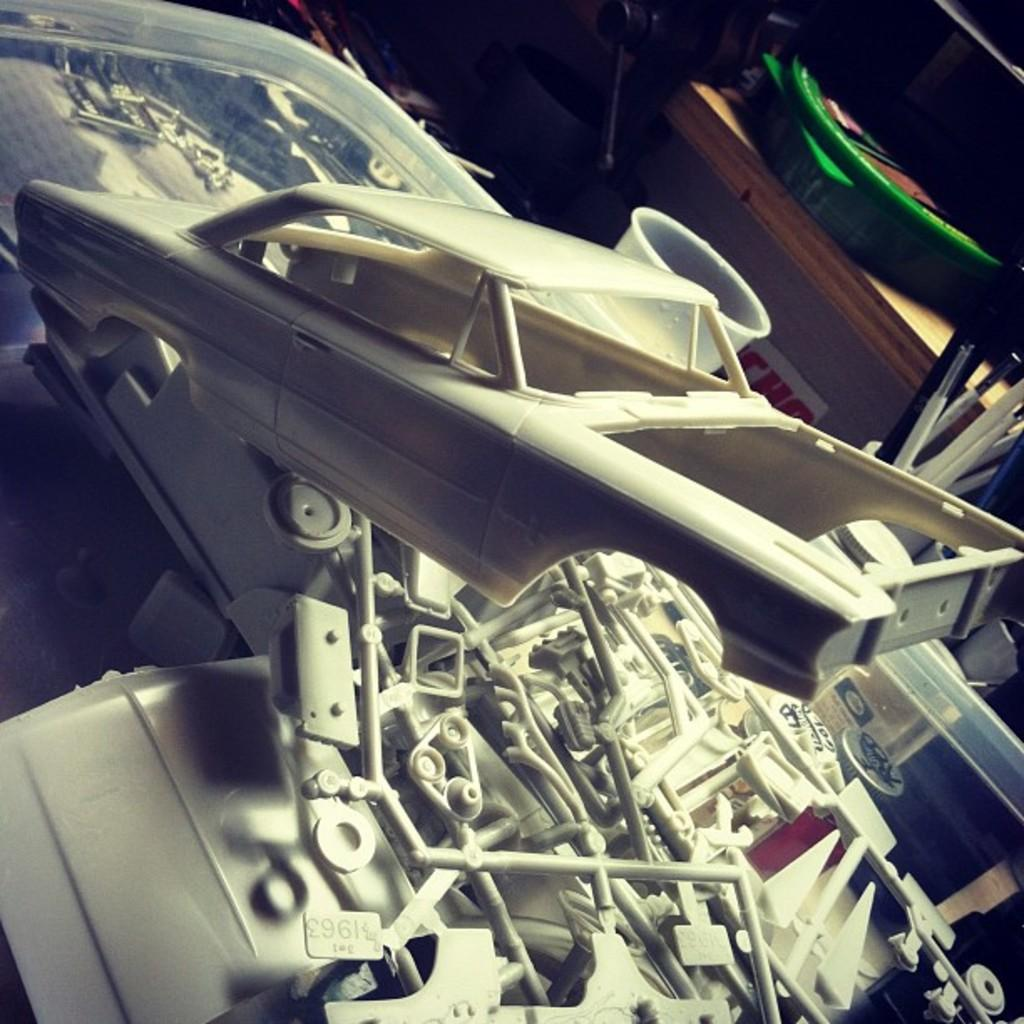What type of objects can be seen in the image? There are toy vehicle parts in the image. What else is present in the image besides the toy vehicle parts? There is a cup in the image. What type of quill can be seen in the image? There is no quill present in the image. What reaction can be observed from the toy vehicle parts in the image? The toy vehicle parts are inanimate objects and cannot have reactions. 